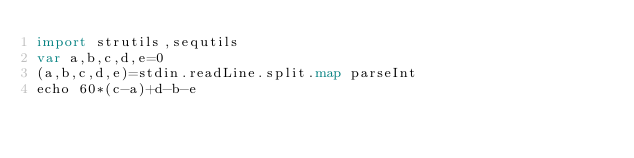<code> <loc_0><loc_0><loc_500><loc_500><_Nim_>import strutils,sequtils
var a,b,c,d,e=0
(a,b,c,d,e)=stdin.readLine.split.map parseInt
echo 60*(c-a)+d-b-e</code> 